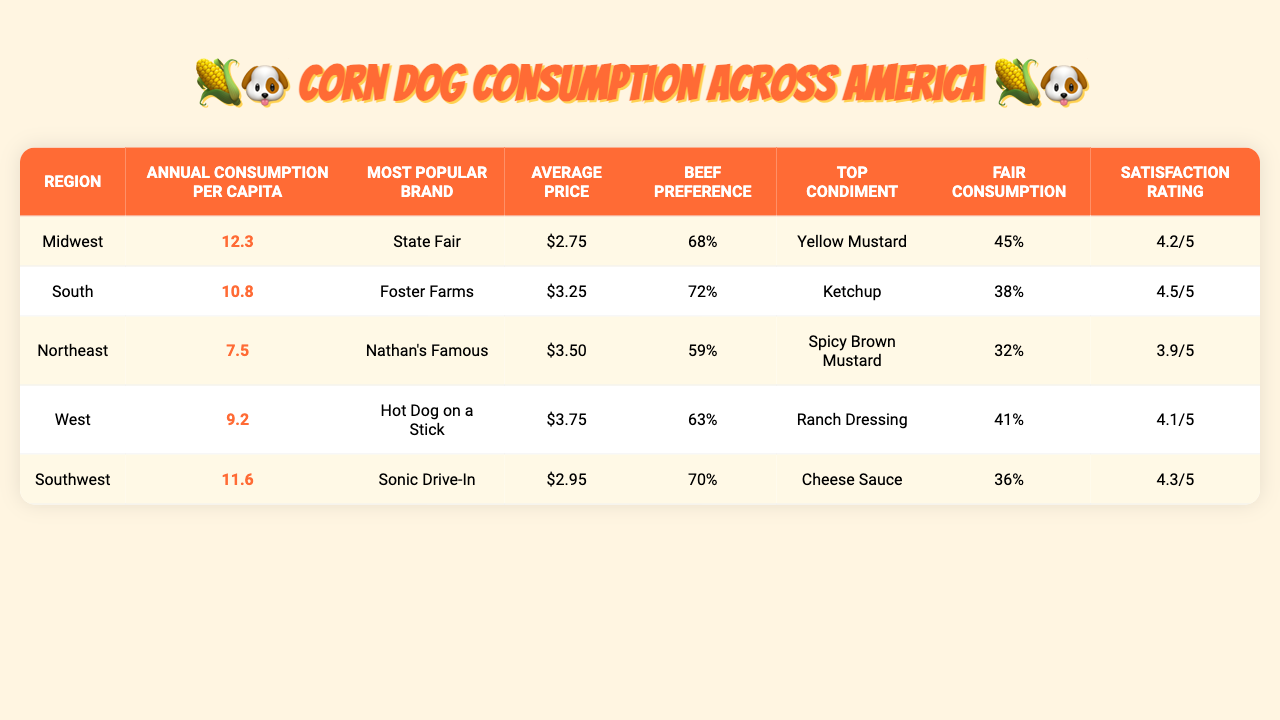What is the annual corn dog consumption per capita in the Midwest? According to the table, the annual consumption per capita in the Midwest is listed directly, which is 12.3.
Answer: 12.3 Which region has the highest average customer satisfaction rating? Looking at the "Average Customer Satisfaction Rating" column, the highest rating is 4.5, found in the South region.
Answer: South What is the most popular corn dog brand in the Southwest? The "Most Popular Corn Dog Brand" for the Southwest region is provided in the table, and it is Sonic Drive-In.
Answer: Sonic Drive-In What percentage of corn dog consumers in the Northeast prefer beef corn dogs? The table indicates that 59% of corn dog consumers in the Northeast prefer beef corn dogs; this is explicitly mentioned in the "Percentage Preferring Beef Corn Dogs" column.
Answer: 59% What is the average price per corn dog in the South? The average price for a corn dog in the South is $3.25, which is directly stated in the "Average Price Per Corn Dog" column.
Answer: $3.25 Which region has the lowest consumption percentage at fairs and festivals? By examining the "Percentage Consumed at Fairs and Festivals" column, we see that the Northeast, with 32%, has the lowest percentage.
Answer: Northeast How many more corn dogs are consumed per capita in the Midwest compared to the Northeast? The Midwest has an annual consumption of 12.3, and the Northeast has 7.5. The difference is calculated as 12.3 - 7.5 = 4.8.
Answer: 4.8 Is the percentage of people preferring beef corn dogs in the South higher or lower than that in the West? The South has 72% preferring beef corn dogs, while the West has 63%. Since 72 is higher than 63, the answer is higher.
Answer: Higher What is the overall average price of corn dogs across all regions? Adding all the average prices ($2.75 + $3.25 + $3.50 + $3.75 + $2.95 = $15.50) and dividing by 5 gives an average price of $3.10.
Answer: $3.10 Which condiment pairing is most common in the Midwest? The table shows that the top condiment pairing in the Midwest is Yellow Mustard, which is specifically listed in the "Top Condiment Pairing" column.
Answer: Yellow Mustard Calculate the average annual corn dog consumption for all regions combined. Summing the annual consumptions (12.3 + 10.8 + 7.5 + 9.2 + 11.6 = 51.4) and dividing by 5 gives an average of 10.28.
Answer: 10.28 What percentage of corn dog consumers in the West consume them at fairs and festivals? According to the table, the percentage of corn dogs consumed at fairs and festivals in the West is 41%.
Answer: 41% Which region consumes the least corn dogs per capita? Comparing the annual consumption per capita, the Northeast at 7.5 has the lowest value, making it the least consuming region per capita.
Answer: Northeast Do more than 70% of consumers in the South prefer beef corn dogs? The South is reported as having 72% preference for beef corn dogs. Since 72 is greater than 70, the answer is yes.
Answer: Yes How does the average satisfaction rating in the Midwest compare to that in the South? The Midwest has a satisfaction rating of 4.2, while the South has 4.5. Since 4.2 is less than 4.5, the Midwest has a lower rating.
Answer: Lower 